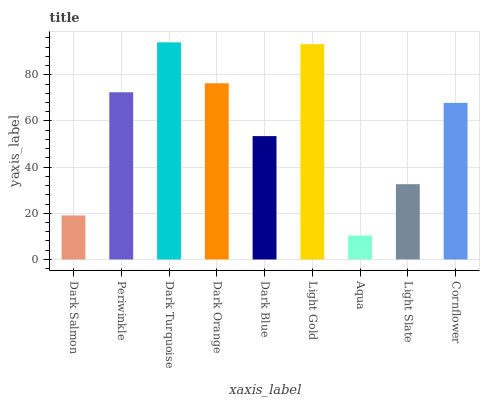Is Periwinkle the minimum?
Answer yes or no. No. Is Periwinkle the maximum?
Answer yes or no. No. Is Periwinkle greater than Dark Salmon?
Answer yes or no. Yes. Is Dark Salmon less than Periwinkle?
Answer yes or no. Yes. Is Dark Salmon greater than Periwinkle?
Answer yes or no. No. Is Periwinkle less than Dark Salmon?
Answer yes or no. No. Is Cornflower the high median?
Answer yes or no. Yes. Is Cornflower the low median?
Answer yes or no. Yes. Is Periwinkle the high median?
Answer yes or no. No. Is Dark Blue the low median?
Answer yes or no. No. 